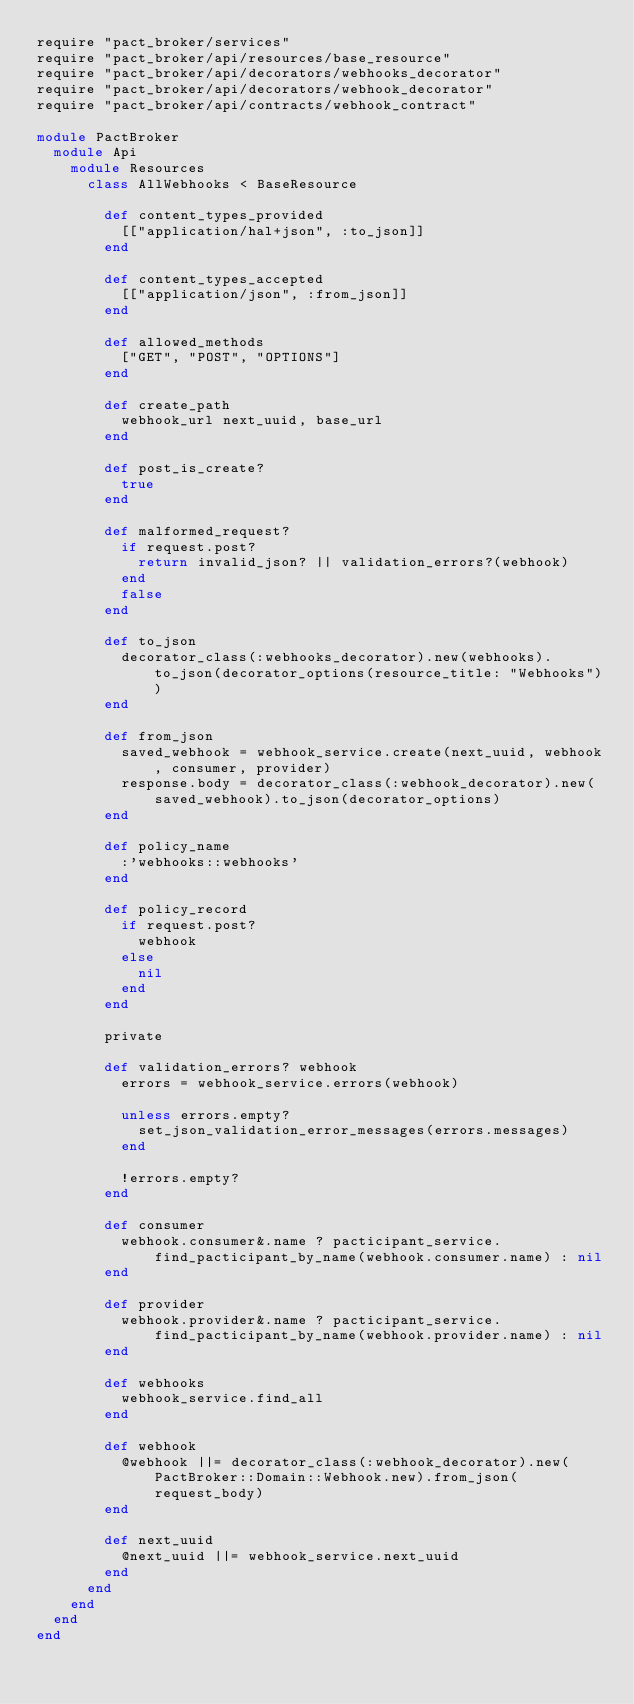Convert code to text. <code><loc_0><loc_0><loc_500><loc_500><_Ruby_>require "pact_broker/services"
require "pact_broker/api/resources/base_resource"
require "pact_broker/api/decorators/webhooks_decorator"
require "pact_broker/api/decorators/webhook_decorator"
require "pact_broker/api/contracts/webhook_contract"

module PactBroker
  module Api
    module Resources
      class AllWebhooks < BaseResource

        def content_types_provided
          [["application/hal+json", :to_json]]
        end

        def content_types_accepted
          [["application/json", :from_json]]
        end

        def allowed_methods
          ["GET", "POST", "OPTIONS"]
        end

        def create_path
          webhook_url next_uuid, base_url
        end

        def post_is_create?
          true
        end

        def malformed_request?
          if request.post?
            return invalid_json? || validation_errors?(webhook)
          end
          false
        end

        def to_json
          decorator_class(:webhooks_decorator).new(webhooks).to_json(decorator_options(resource_title: "Webhooks"))
        end

        def from_json
          saved_webhook = webhook_service.create(next_uuid, webhook, consumer, provider)
          response.body = decorator_class(:webhook_decorator).new(saved_webhook).to_json(decorator_options)
        end

        def policy_name
          :'webhooks::webhooks'
        end

        def policy_record
          if request.post?
            webhook
          else
            nil
          end
        end

        private

        def validation_errors? webhook
          errors = webhook_service.errors(webhook)

          unless errors.empty?
            set_json_validation_error_messages(errors.messages)
          end

          !errors.empty?
        end

        def consumer
          webhook.consumer&.name ? pacticipant_service.find_pacticipant_by_name(webhook.consumer.name) : nil
        end

        def provider
          webhook.provider&.name ? pacticipant_service.find_pacticipant_by_name(webhook.provider.name) : nil
        end

        def webhooks
          webhook_service.find_all
        end

        def webhook
          @webhook ||= decorator_class(:webhook_decorator).new(PactBroker::Domain::Webhook.new).from_json(request_body)
        end

        def next_uuid
          @next_uuid ||= webhook_service.next_uuid
        end
      end
    end
  end
end
</code> 